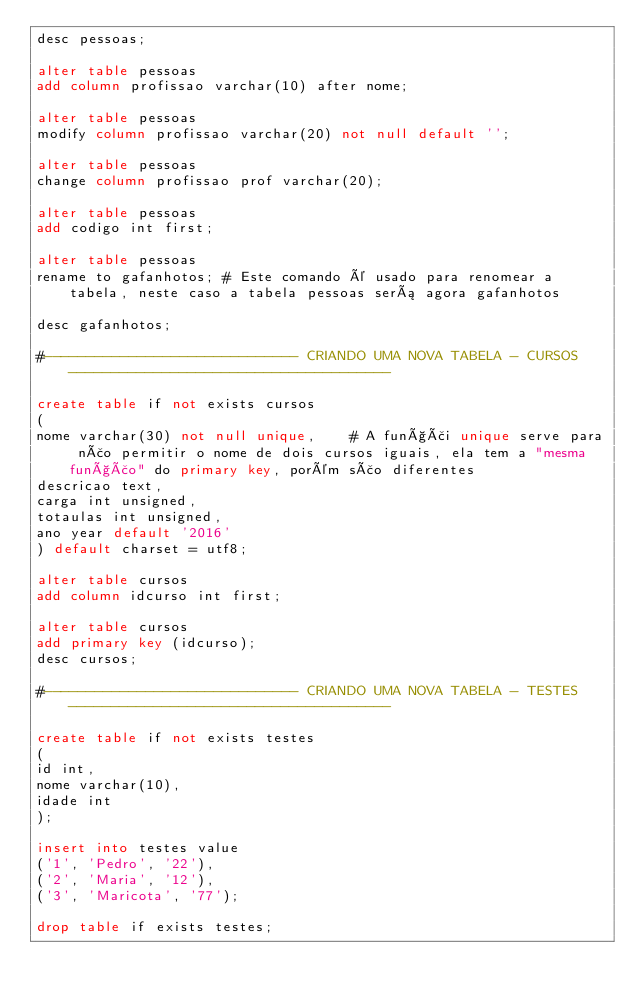Convert code to text. <code><loc_0><loc_0><loc_500><loc_500><_SQL_>desc pessoas;

alter table pessoas
add column profissao varchar(10) after nome;

alter table pessoas
modify column profissao varchar(20) not null default '';

alter table pessoas
change column profissao prof varchar(20);

alter table pessoas
add codigo int first;

alter table pessoas
rename to gafanhotos; # Este comando é usado para renomear a tabela, neste caso a tabela pessoas será agora gafanhotos

desc gafanhotos;

#------------------------------ CRIANDO UMA NOVA TABELA - CURSOS --------------------------------------

create table if not exists cursos
(
nome varchar(30) not null unique,    # A funçãi unique serve para não permitir o nome de dois cursos iguais, ela tem a "mesma função" do primary key, porém são diferentes
descricao text,
carga int unsigned,
totaulas int unsigned,
ano year default '2016'
) default charset = utf8;

alter table cursos
add column idcurso int first;

alter table cursos
add primary key (idcurso);
desc cursos;

#------------------------------ CRIANDO UMA NOVA TABELA - TESTES --------------------------------------

create table if not exists testes
(
id int,
nome varchar(10),
idade int
);

insert into testes value
('1', 'Pedro', '22'),
('2', 'Maria', '12'),
('3', 'Maricota', '77');

drop table if exists testes;

</code> 